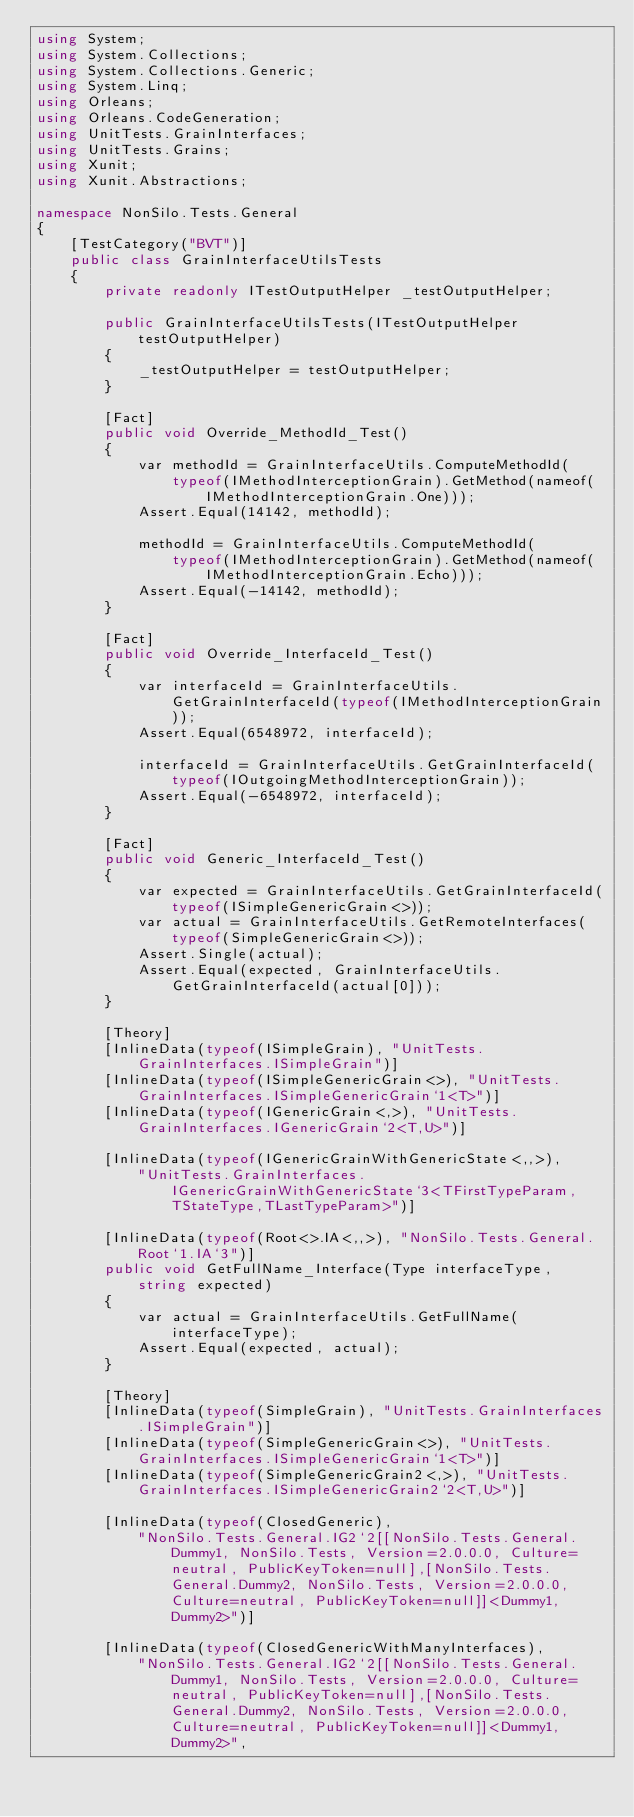Convert code to text. <code><loc_0><loc_0><loc_500><loc_500><_C#_>using System;
using System.Collections;
using System.Collections.Generic;
using System.Linq;
using Orleans;
using Orleans.CodeGeneration;
using UnitTests.GrainInterfaces;
using UnitTests.Grains;
using Xunit;
using Xunit.Abstractions;

namespace NonSilo.Tests.General
{
    [TestCategory("BVT")]
    public class GrainInterfaceUtilsTests
    {
        private readonly ITestOutputHelper _testOutputHelper;

        public GrainInterfaceUtilsTests(ITestOutputHelper testOutputHelper)
        {
            _testOutputHelper = testOutputHelper;
        }

        [Fact]
        public void Override_MethodId_Test()
        {
            var methodId = GrainInterfaceUtils.ComputeMethodId(
                typeof(IMethodInterceptionGrain).GetMethod(nameof(IMethodInterceptionGrain.One)));
            Assert.Equal(14142, methodId);

            methodId = GrainInterfaceUtils.ComputeMethodId(
                typeof(IMethodInterceptionGrain).GetMethod(nameof(IMethodInterceptionGrain.Echo)));
            Assert.Equal(-14142, methodId);
        }

        [Fact]
        public void Override_InterfaceId_Test()
        {
            var interfaceId = GrainInterfaceUtils.GetGrainInterfaceId(typeof(IMethodInterceptionGrain));
            Assert.Equal(6548972, interfaceId);

            interfaceId = GrainInterfaceUtils.GetGrainInterfaceId(typeof(IOutgoingMethodInterceptionGrain));
            Assert.Equal(-6548972, interfaceId);
        }

        [Fact]
        public void Generic_InterfaceId_Test()
        {
            var expected = GrainInterfaceUtils.GetGrainInterfaceId(typeof(ISimpleGenericGrain<>));
            var actual = GrainInterfaceUtils.GetRemoteInterfaces(typeof(SimpleGenericGrain<>));
            Assert.Single(actual);
            Assert.Equal(expected, GrainInterfaceUtils.GetGrainInterfaceId(actual[0]));
        }

        [Theory]
        [InlineData(typeof(ISimpleGrain), "UnitTests.GrainInterfaces.ISimpleGrain")]
        [InlineData(typeof(ISimpleGenericGrain<>), "UnitTests.GrainInterfaces.ISimpleGenericGrain`1<T>")]
        [InlineData(typeof(IGenericGrain<,>), "UnitTests.GrainInterfaces.IGenericGrain`2<T,U>")]

        [InlineData(typeof(IGenericGrainWithGenericState<,,>),
            "UnitTests.GrainInterfaces.IGenericGrainWithGenericState`3<TFirstTypeParam,TStateType,TLastTypeParam>")]

        [InlineData(typeof(Root<>.IA<,,>), "NonSilo.Tests.General.Root`1.IA`3")]
        public void GetFullName_Interface(Type interfaceType, string expected)
        {
            var actual = GrainInterfaceUtils.GetFullName(interfaceType);
            Assert.Equal(expected, actual);
        }

        [Theory]
        [InlineData(typeof(SimpleGrain), "UnitTests.GrainInterfaces.ISimpleGrain")]
        [InlineData(typeof(SimpleGenericGrain<>), "UnitTests.GrainInterfaces.ISimpleGenericGrain`1<T>")]
        [InlineData(typeof(SimpleGenericGrain2<,>), "UnitTests.GrainInterfaces.ISimpleGenericGrain2`2<T,U>")]

        [InlineData(typeof(ClosedGeneric),
            "NonSilo.Tests.General.IG2`2[[NonSilo.Tests.General.Dummy1, NonSilo.Tests, Version=2.0.0.0, Culture=neutral, PublicKeyToken=null],[NonSilo.Tests.General.Dummy2, NonSilo.Tests, Version=2.0.0.0, Culture=neutral, PublicKeyToken=null]]<Dummy1,Dummy2>")]

        [InlineData(typeof(ClosedGenericWithManyInterfaces),
            "NonSilo.Tests.General.IG2`2[[NonSilo.Tests.General.Dummy1, NonSilo.Tests, Version=2.0.0.0, Culture=neutral, PublicKeyToken=null],[NonSilo.Tests.General.Dummy2, NonSilo.Tests, Version=2.0.0.0, Culture=neutral, PublicKeyToken=null]]<Dummy1,Dummy2>",</code> 